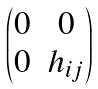<formula> <loc_0><loc_0><loc_500><loc_500>\begin{pmatrix} 0 & 0 \\ 0 & h _ { i j } \end{pmatrix}</formula> 